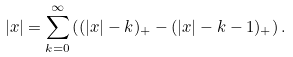<formula> <loc_0><loc_0><loc_500><loc_500>| x | = \sum _ { k = 0 } ^ { \infty } \left ( ( | x | - k ) _ { + } - ( | x | - k - 1 ) _ { + } \right ) .</formula> 